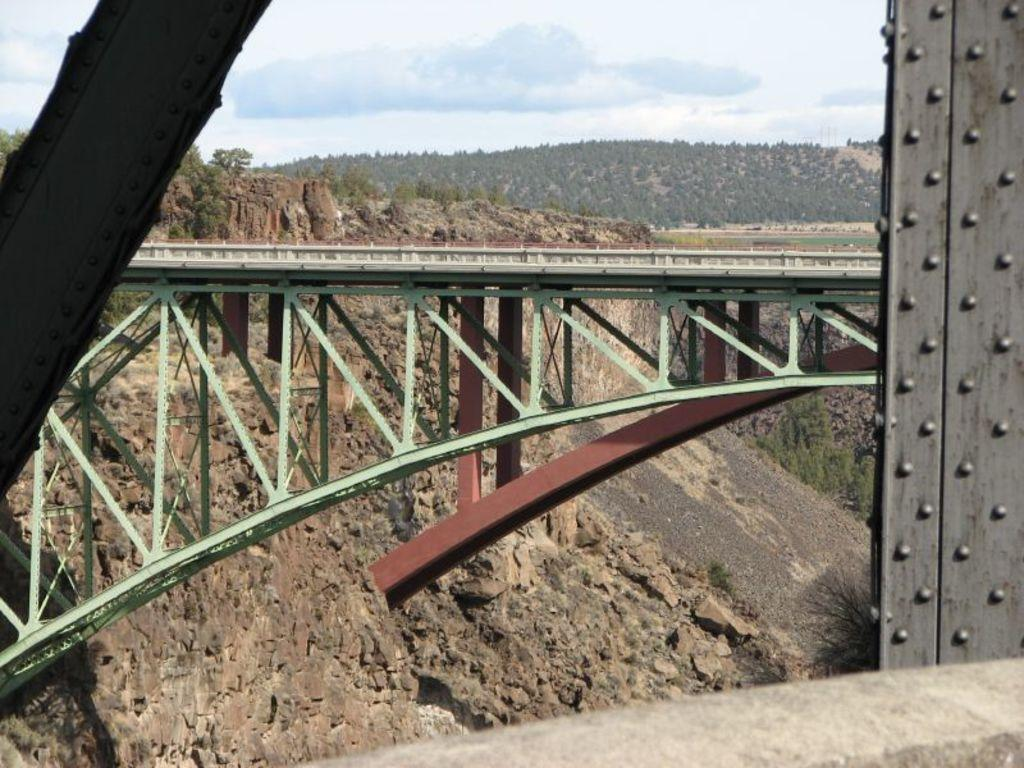What structure is located in the middle of the image? There is a bridge in the middle of the image. What type of vegetation can be seen in the background of the image? There are trees in the background of the image. What is visible at the top of the image? The sky is visible at the top of the image. Where is the soap located in the image? There is no soap present in the image. What type of parcel can be seen being delivered in the image? There is no parcel delivery depicted in the image. 